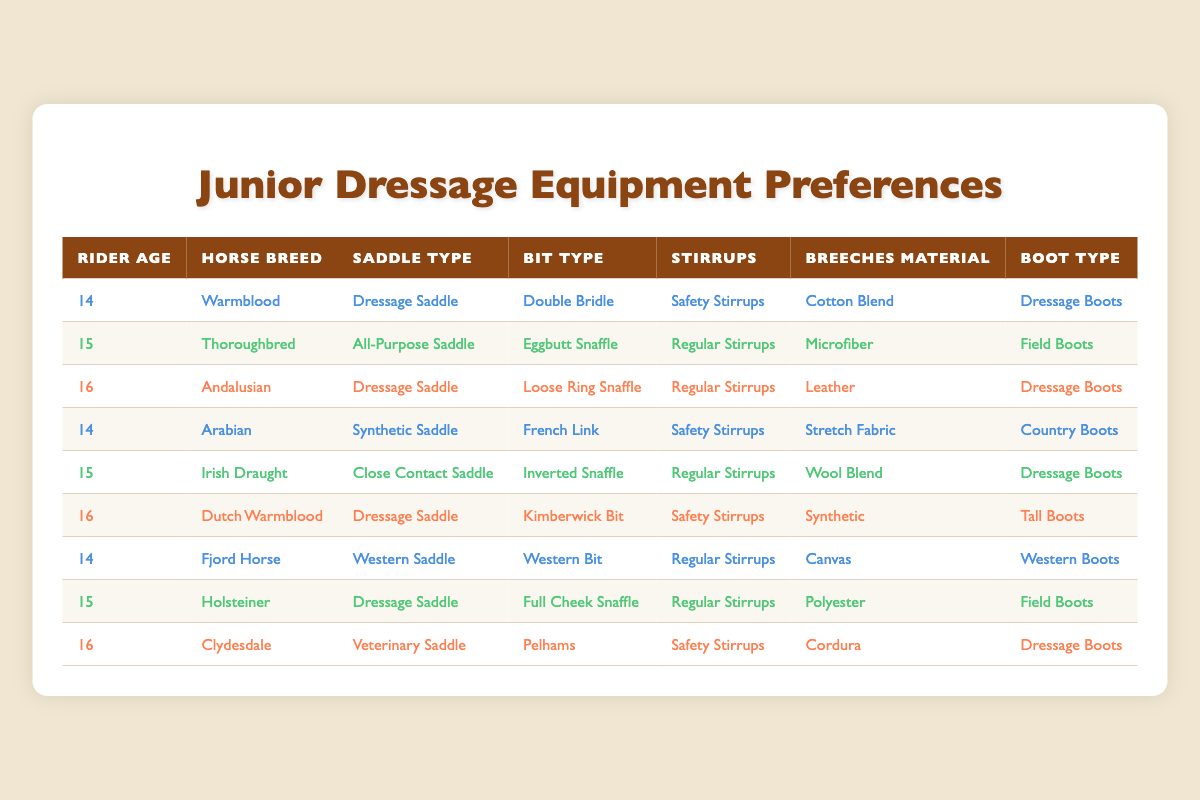What is the most common saddle type among the riders in the table? By examining the "Saddle Type" column, I can see that "Dressage Saddle" appears four times, while other saddle types appear less frequently. Thus, the most common saddle type is "Dressage Saddle."
Answer: Dressage Saddle How many riders are using safety stirrups? By checking the "Stirrups" column, I can identify the rows where "Safety Stirrups" is mentioned. There are three rows that indicate the use of safety stirrups.
Answer: 3 Which horse breed is associated with the youngest rider? By looking at the "Rider Age" column, the youngest age is 14. I will reference the same row to see which horse breed is linked to this age. The associated horse breed is "Warmblood."
Answer: Warmblood Are there any riders using a Western saddle? In the "Saddle Type" column, I will search for "Western Saddle." There is one instance of a rider using this type of saddle, so the answer is yes.
Answer: Yes What is the average age of the riders? The ages listed are 14, 15, 16, 14, 15, 16, 14, 15, and 16. The sum of these ages is 14 + 15 + 16 + 14 + 15 + 16 + 14 + 15 + 16 = 135. There are 9 riders, so the average is 135 / 9 = 15.
Answer: 15 Which horse breed is exclusively linked to riders aged 15? I will look at the rows associated with age 15. The horse breeds listed for this age are "Thoroughbred," "Irish Draught," and "Holsteiner." Since there are multiple breeds, none is exclusively linked to riders aged 15.
Answer: None Do all riders use regular stirrups? In the "Stirrups" column, I check for instances of "Regular Stirrups" versus "Safety Stirrups." Not every rider has "Regular Stirrups." Thus, the answer is no.
Answer: No How many different boot types are mentioned? By analyzing the "Boot Type" column, I can list the unique types: "Dressage Boots," "Field Boots," "Country Boots," "Western Boots," and "Tall Boots." There are five different boot types in total.
Answer: 5 What type of bit is used by the rider with the "Close Contact Saddle"? I will locate "Close Contact Saddle" in the "Saddle Type" column, which corresponds to the rider aged 15, and check the "Bit Type" for that row. The bit type in that row is "Inverted Snaffle."
Answer: Inverted Snaffle 